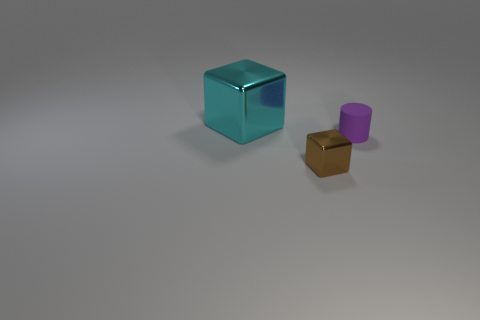Is the number of big cubes greater than the number of tiny red matte blocks?
Offer a very short reply. Yes. What number of things are either shiny blocks that are in front of the purple cylinder or tiny metallic spheres?
Offer a very short reply. 1. Do the tiny brown thing and the big cyan thing have the same material?
Your answer should be very brief. Yes. There is another thing that is the same shape as the tiny metallic object; what size is it?
Make the answer very short. Large. There is a metallic object that is in front of the big metallic object; is its shape the same as the tiny object that is behind the tiny shiny thing?
Your response must be concise. No. There is a brown block; is its size the same as the object that is right of the small metallic block?
Give a very brief answer. Yes. How many other things are the same material as the big cyan thing?
Offer a very short reply. 1. Are there any other things that are the same shape as the purple rubber object?
Give a very brief answer. No. There is a block that is in front of the metallic block behind the metal object that is on the right side of the large cyan metal object; what is its color?
Your answer should be compact. Brown. There is a thing that is right of the cyan object and on the left side of the matte thing; what is its shape?
Provide a succinct answer. Cube. 